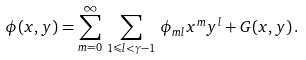Convert formula to latex. <formula><loc_0><loc_0><loc_500><loc_500>\phi ( x , y ) = \sum _ { m = 0 } ^ { \infty } \, \sum _ { 1 \leqslant l < \gamma - 1 } \, \phi _ { m l } x ^ { m } y ^ { l } + G ( x , y ) \, .</formula> 